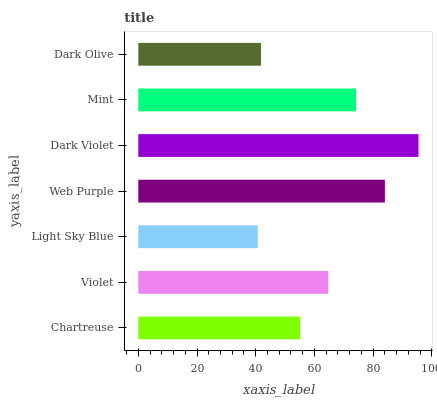Is Light Sky Blue the minimum?
Answer yes or no. Yes. Is Dark Violet the maximum?
Answer yes or no. Yes. Is Violet the minimum?
Answer yes or no. No. Is Violet the maximum?
Answer yes or no. No. Is Violet greater than Chartreuse?
Answer yes or no. Yes. Is Chartreuse less than Violet?
Answer yes or no. Yes. Is Chartreuse greater than Violet?
Answer yes or no. No. Is Violet less than Chartreuse?
Answer yes or no. No. Is Violet the high median?
Answer yes or no. Yes. Is Violet the low median?
Answer yes or no. Yes. Is Dark Violet the high median?
Answer yes or no. No. Is Dark Violet the low median?
Answer yes or no. No. 